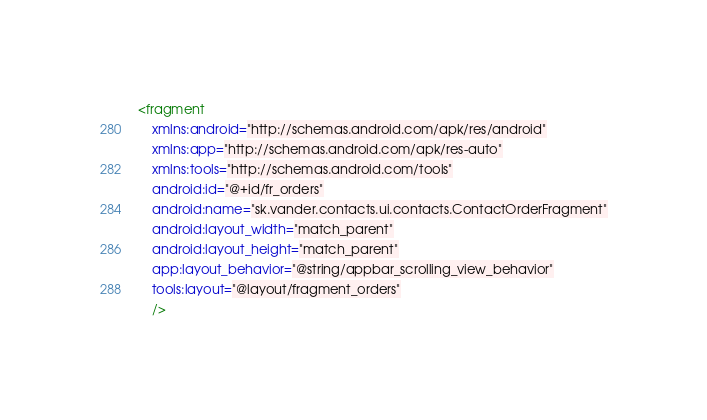<code> <loc_0><loc_0><loc_500><loc_500><_XML_><fragment
    xmlns:android="http://schemas.android.com/apk/res/android"
    xmlns:app="http://schemas.android.com/apk/res-auto"
    xmlns:tools="http://schemas.android.com/tools"
    android:id="@+id/fr_orders"
    android:name="sk.vander.contacts.ui.contacts.ContactOrderFragment"
    android:layout_width="match_parent"
    android:layout_height="match_parent"
    app:layout_behavior="@string/appbar_scrolling_view_behavior"
    tools:layout="@layout/fragment_orders"
    />
</code> 